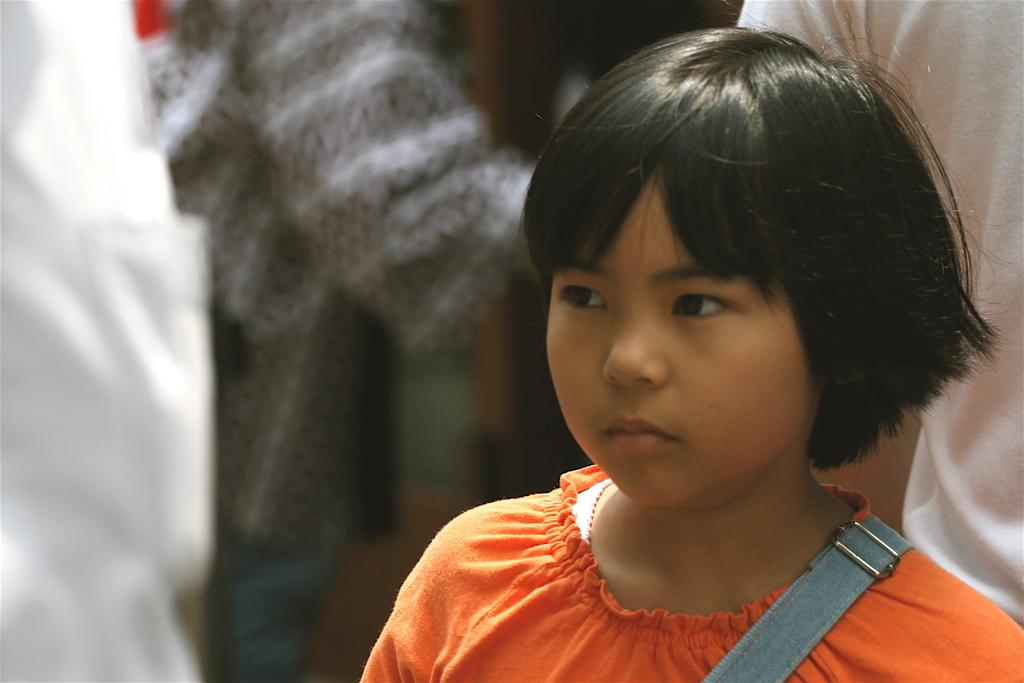What is being worn by the girl in the image? There is a belt on a girl in the image. Can you describe the setting in which the girl is located? The girl is in a setting where there are people in the background of the image. What invention does the girl have an interest in while wearing the belt? There is no indication in the image of any specific invention or interest related to the girl wearing the belt. 